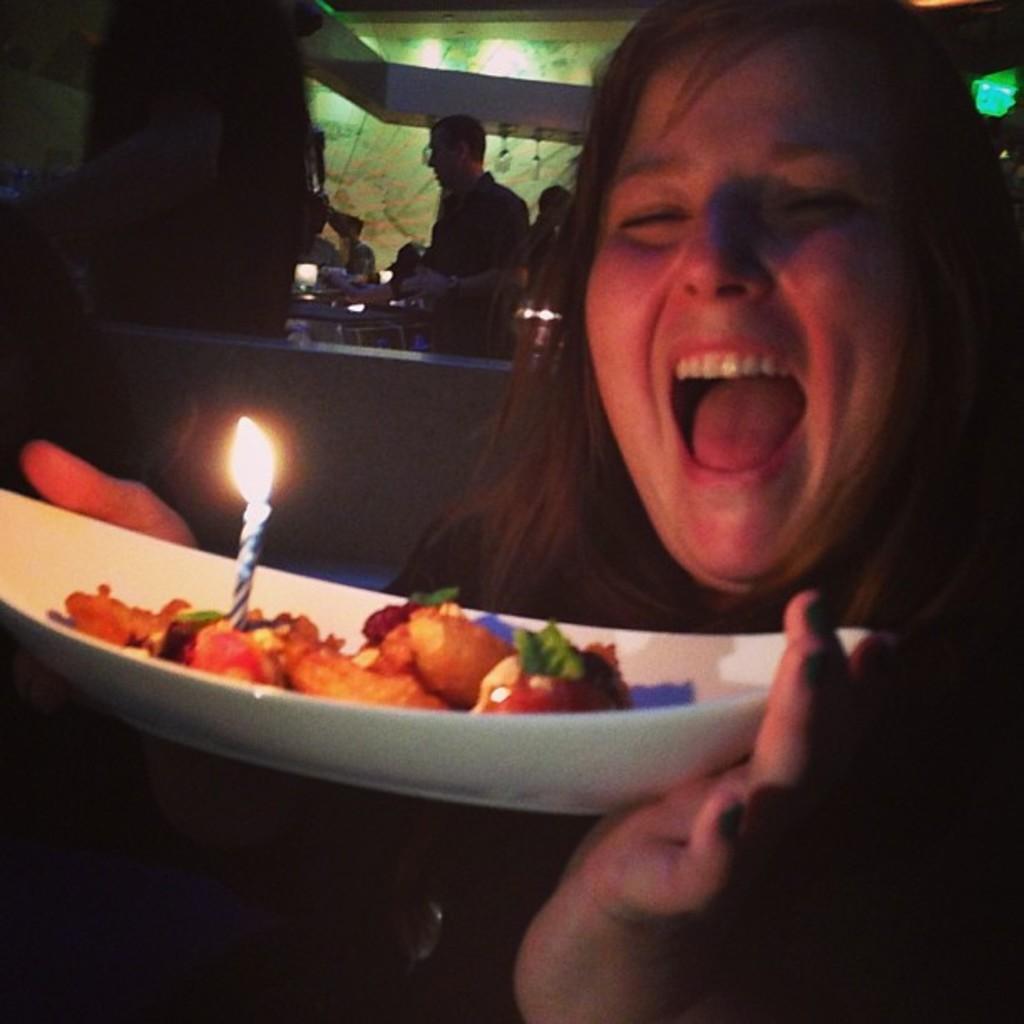Please provide a concise description of this image. In this image we can see woman holding a bowl which consists of candle and wood. In the background we can see persons and wall. 